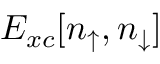Convert formula to latex. <formula><loc_0><loc_0><loc_500><loc_500>E _ { x c } [ n _ { \uparrow } , n _ { \downarrow } ]</formula> 